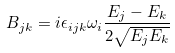Convert formula to latex. <formula><loc_0><loc_0><loc_500><loc_500>B _ { j k } = i \epsilon _ { i j k } \omega _ { i } \frac { E _ { j } - E _ { k } } { 2 \sqrt { E _ { j } E _ { k } } }</formula> 